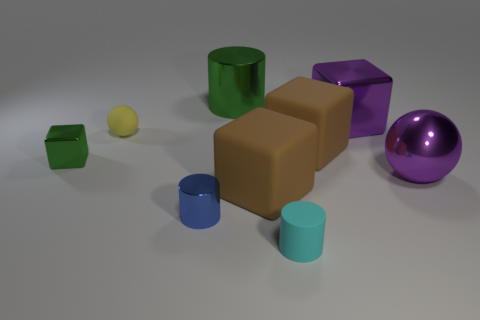Subtract 1 blocks. How many blocks are left? 3 Subtract all gray blocks. Subtract all yellow balls. How many blocks are left? 4 Add 1 metal things. How many objects exist? 10 Subtract all cubes. How many objects are left? 5 Add 3 small blue cylinders. How many small blue cylinders exist? 4 Subtract 1 purple cubes. How many objects are left? 8 Subtract all large green things. Subtract all cubes. How many objects are left? 4 Add 3 small metal things. How many small metal things are left? 5 